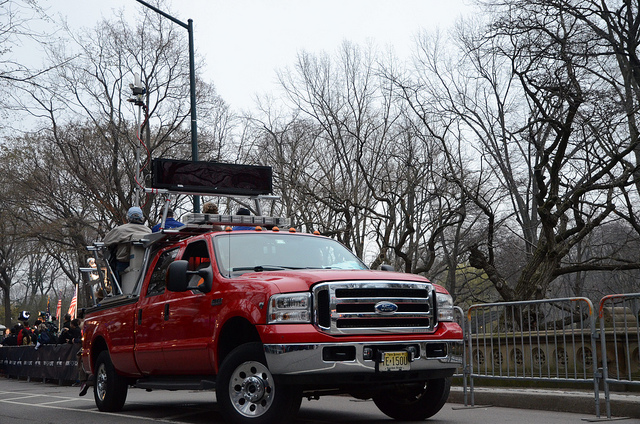Please transcribe the text information in this image. HE-1500 